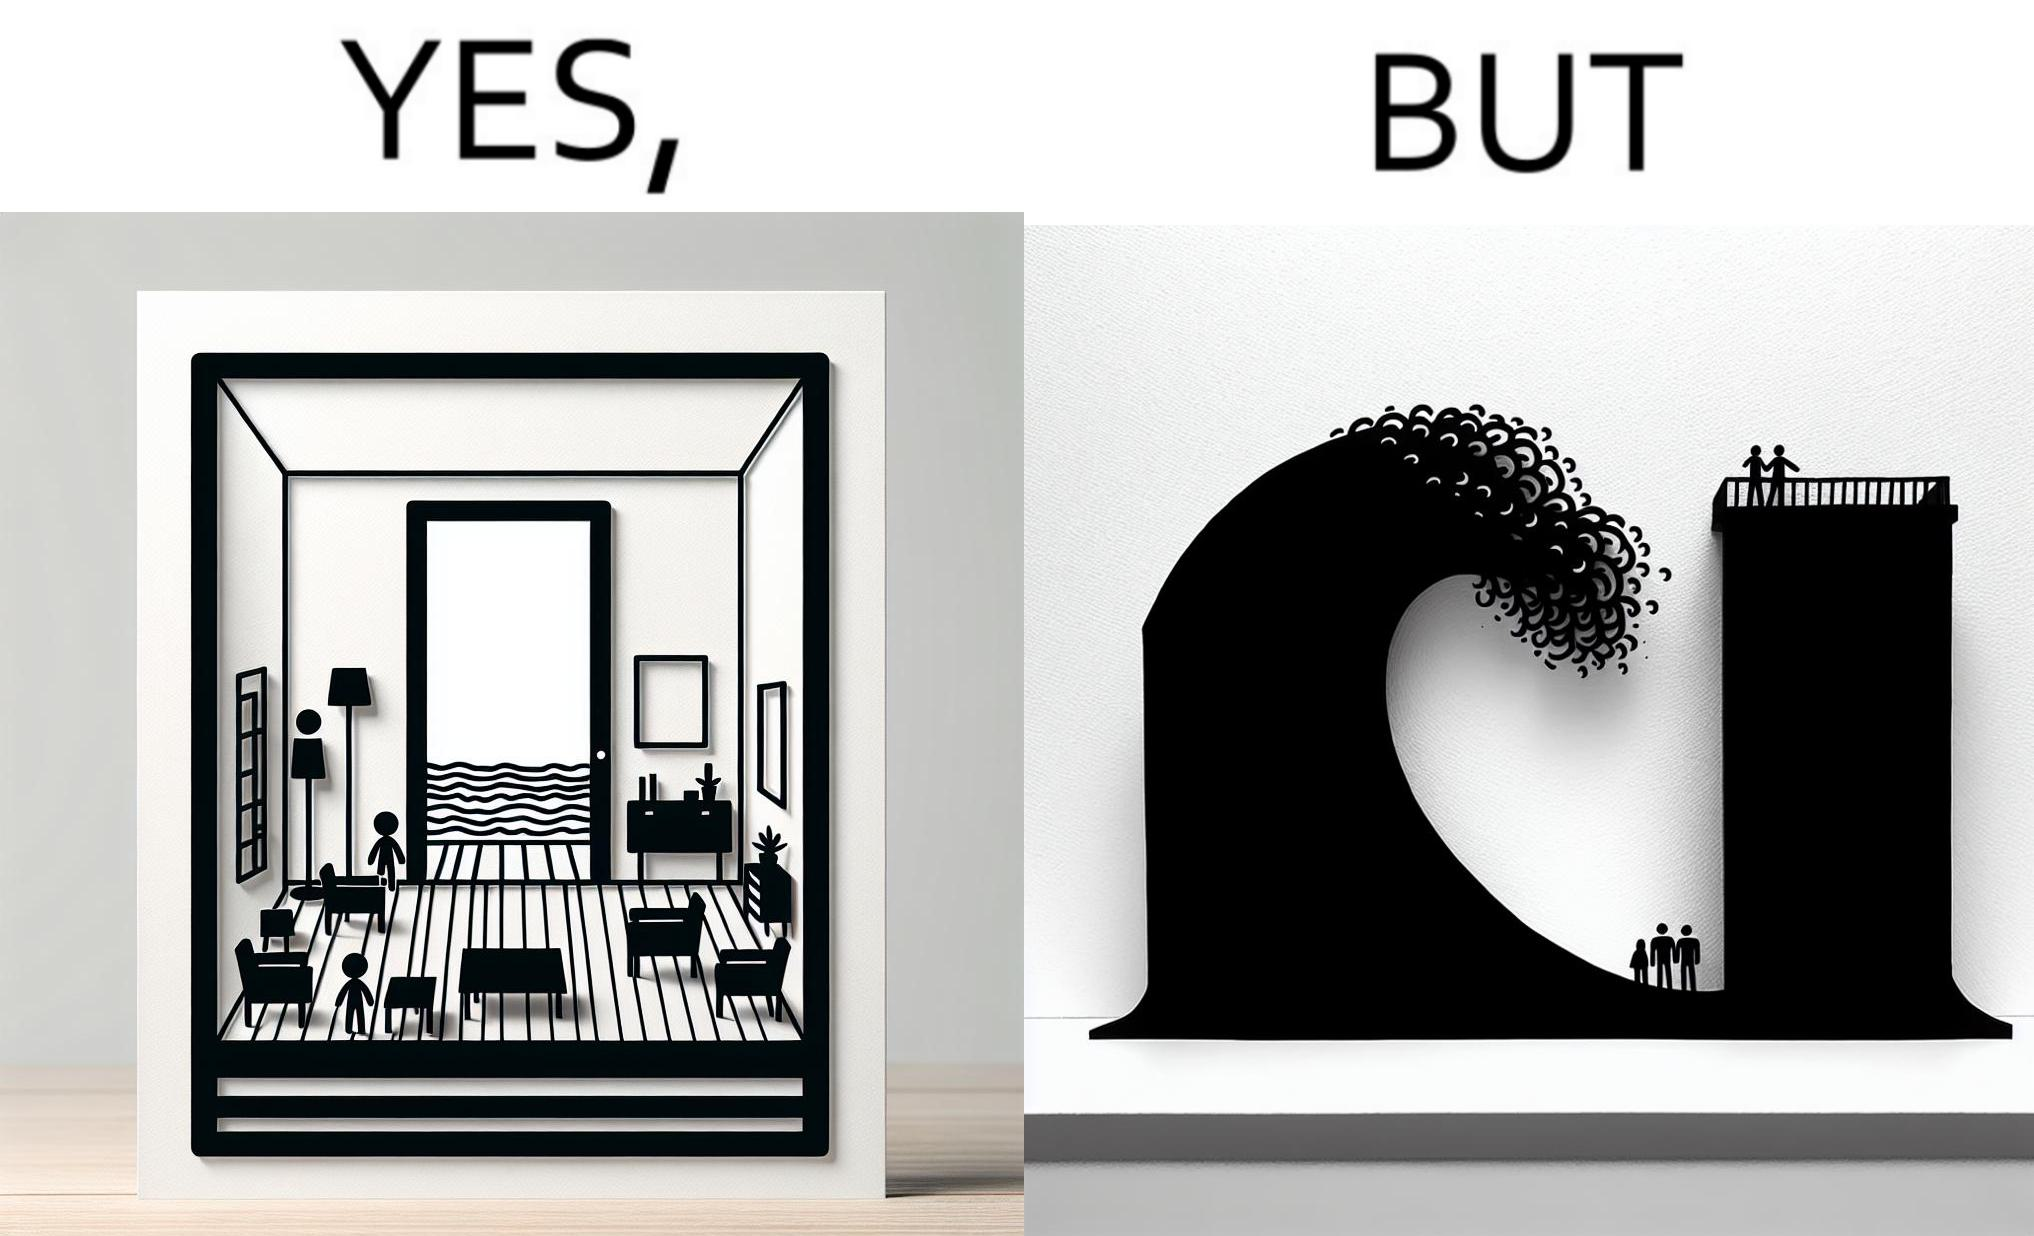Is there satirical content in this image? Yes, this image is satirical. 